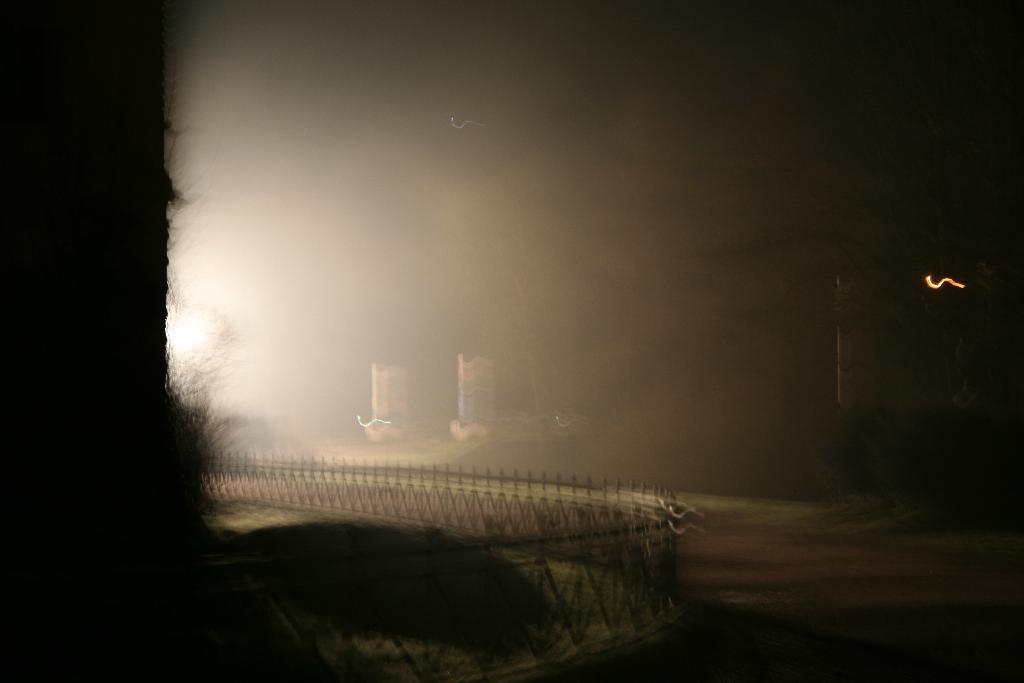How would you summarize this image in a sentence or two? In this picture we can see building. In the bottom we can see the fencing and plants. In the background we can see the trees. 